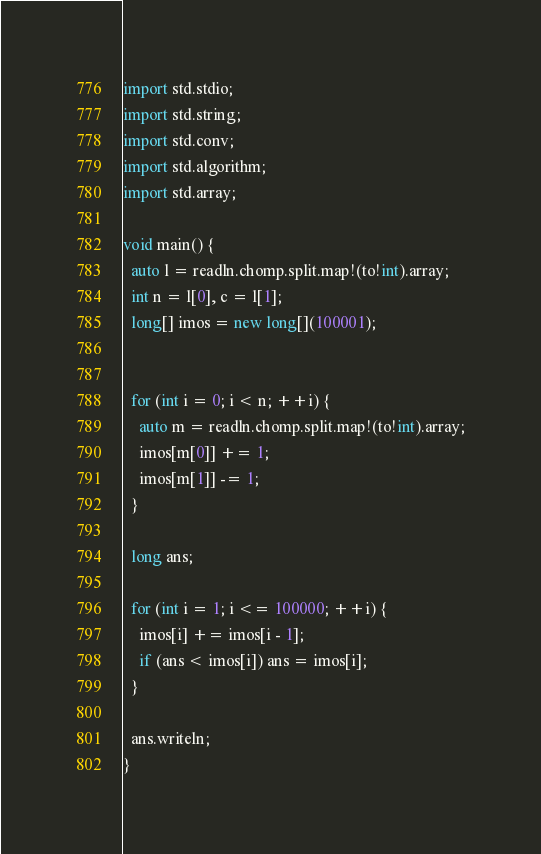<code> <loc_0><loc_0><loc_500><loc_500><_D_>import std.stdio;
import std.string;
import std.conv;
import std.algorithm;
import std.array;

void main() {
  auto l = readln.chomp.split.map!(to!int).array;
  int n = l[0], c = l[1];
  long[] imos = new long[](100001);
  

  for (int i = 0; i < n; ++i) {
    auto m = readln.chomp.split.map!(to!int).array;
    imos[m[0]] += 1;
    imos[m[1]] -= 1;
  }

  long ans;

  for (int i = 1; i <= 100000; ++i) {
    imos[i] += imos[i - 1];
    if (ans < imos[i]) ans = imos[i];
  }

  ans.writeln;
}</code> 